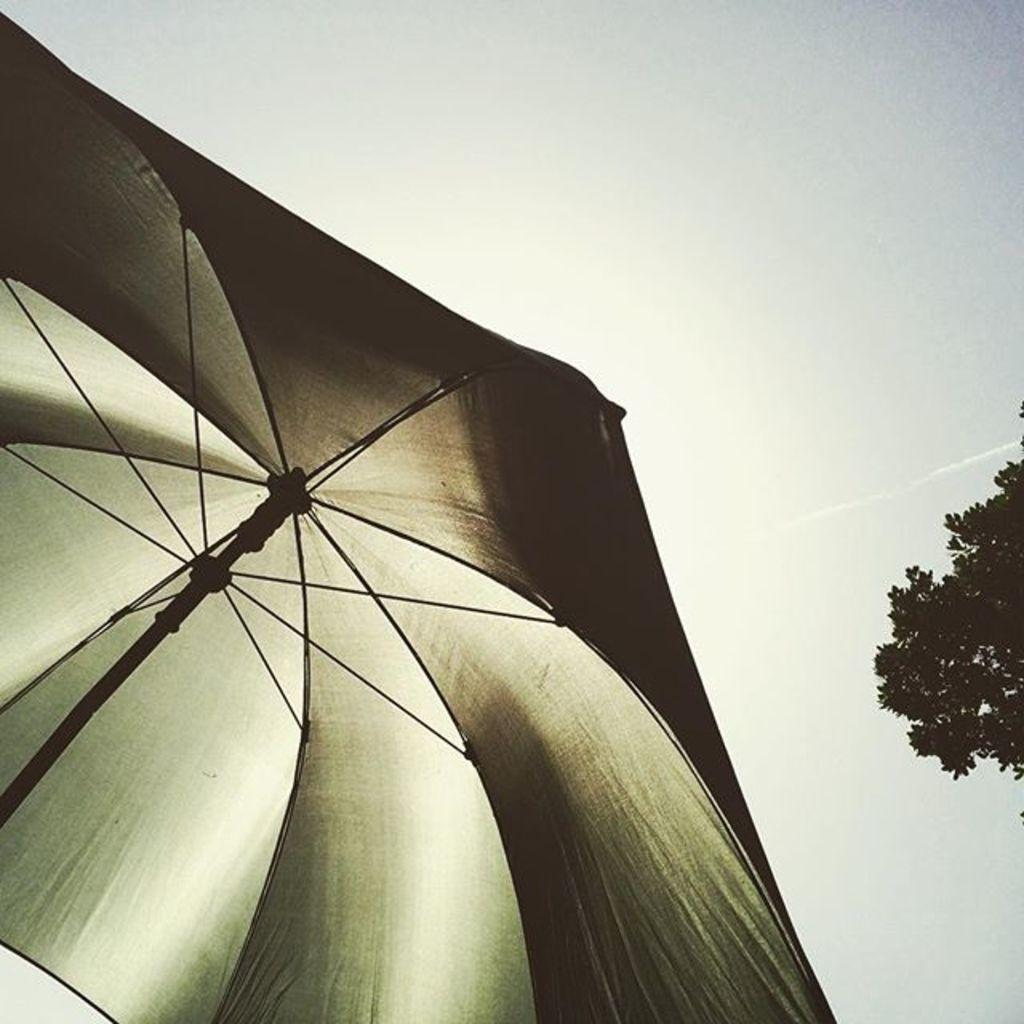What object is present in the image to provide shade or protection from the elements? There is an umbrella in the image. What type of natural element is also present in the image? There is a tree in the image. What can be seen in the background of the image? The sky is visible in the background of the image. What type of plastic material is covering the tree in the image? There is no plastic material covering the tree in the image; it is a natural tree. 